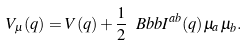Convert formula to latex. <formula><loc_0><loc_0><loc_500><loc_500>V _ { \mu } ( q ) = V ( q ) + \frac { 1 } { 2 } { \ B b b I } ^ { a b } ( q ) \mu _ { a } \mu _ { b } .</formula> 